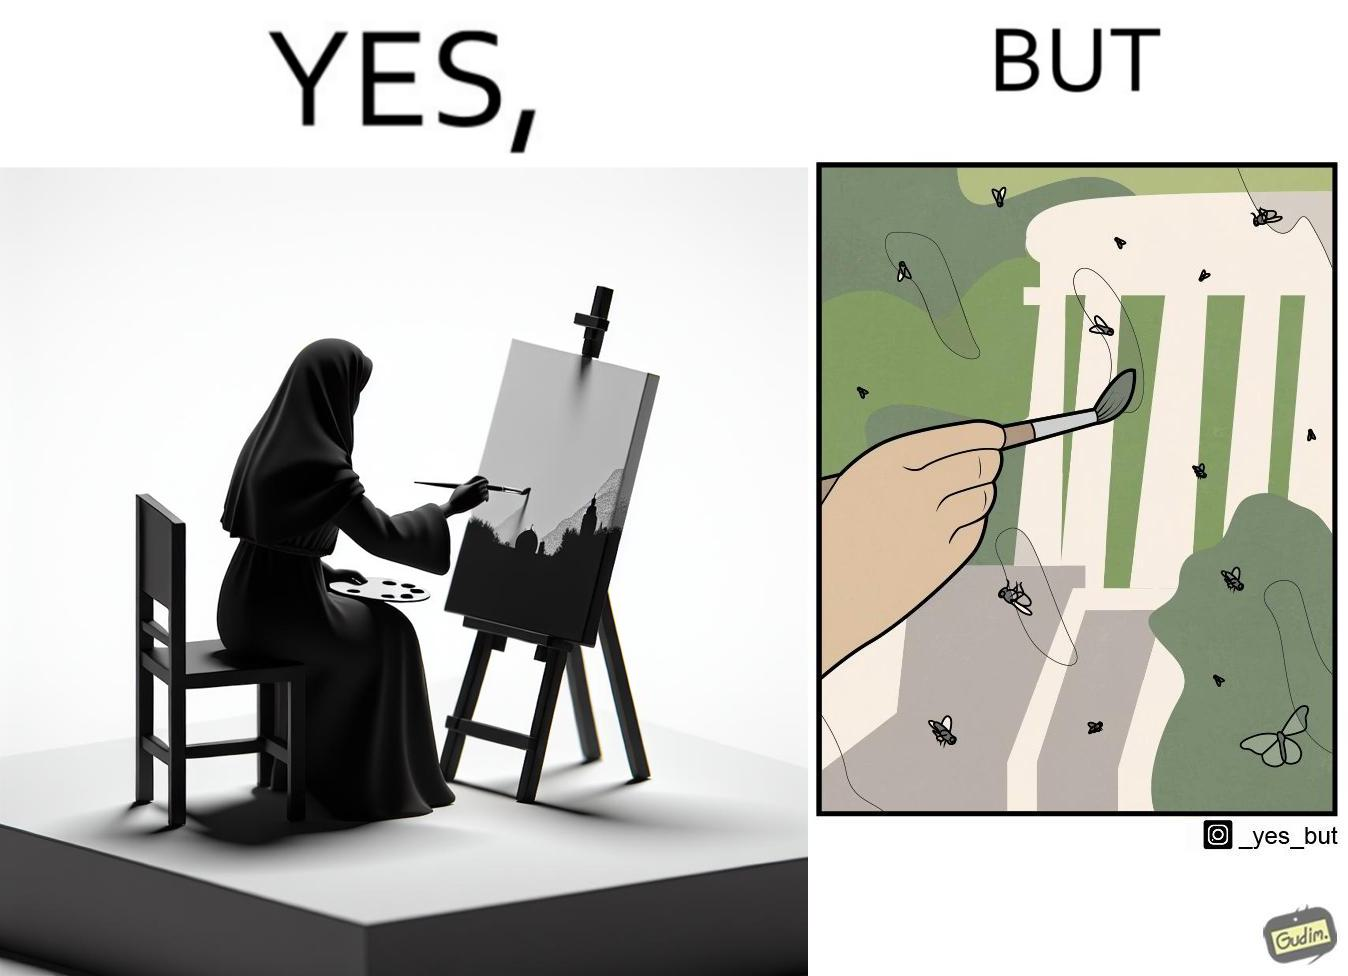What is shown in this image? The images are funny since they show how a peaceful sight like a woman painting a natural scenery looks good only from afar. When looked closely we can see details like flies on the painting which make us uneasy and the scene is not so good to look at anymore. 